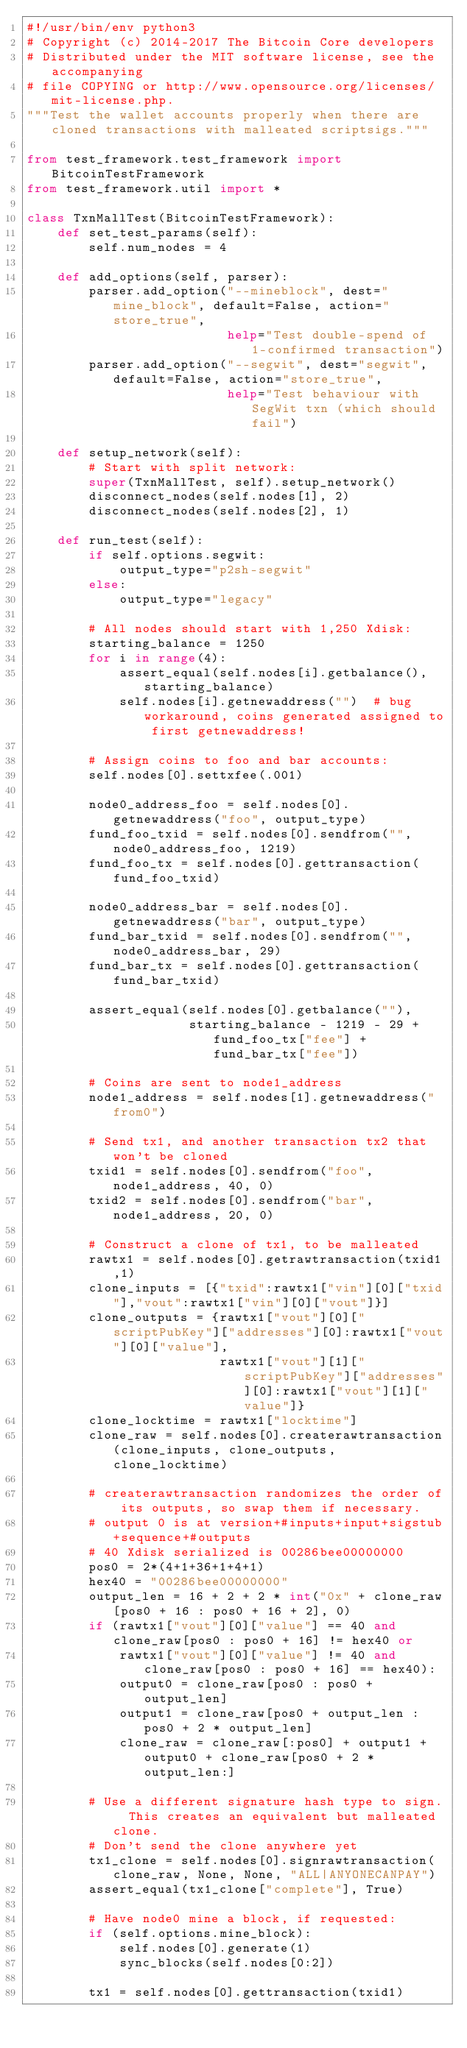<code> <loc_0><loc_0><loc_500><loc_500><_Python_>#!/usr/bin/env python3
# Copyright (c) 2014-2017 The Bitcoin Core developers
# Distributed under the MIT software license, see the accompanying
# file COPYING or http://www.opensource.org/licenses/mit-license.php.
"""Test the wallet accounts properly when there are cloned transactions with malleated scriptsigs."""

from test_framework.test_framework import BitcoinTestFramework
from test_framework.util import *

class TxnMallTest(BitcoinTestFramework):
    def set_test_params(self):
        self.num_nodes = 4

    def add_options(self, parser):
        parser.add_option("--mineblock", dest="mine_block", default=False, action="store_true",
                          help="Test double-spend of 1-confirmed transaction")
        parser.add_option("--segwit", dest="segwit", default=False, action="store_true",
                          help="Test behaviour with SegWit txn (which should fail")

    def setup_network(self):
        # Start with split network:
        super(TxnMallTest, self).setup_network()
        disconnect_nodes(self.nodes[1], 2)
        disconnect_nodes(self.nodes[2], 1)

    def run_test(self):
        if self.options.segwit:
            output_type="p2sh-segwit"
        else:
            output_type="legacy"

        # All nodes should start with 1,250 Xdisk:
        starting_balance = 1250
        for i in range(4):
            assert_equal(self.nodes[i].getbalance(), starting_balance)
            self.nodes[i].getnewaddress("")  # bug workaround, coins generated assigned to first getnewaddress!

        # Assign coins to foo and bar accounts:
        self.nodes[0].settxfee(.001)

        node0_address_foo = self.nodes[0].getnewaddress("foo", output_type)
        fund_foo_txid = self.nodes[0].sendfrom("", node0_address_foo, 1219)
        fund_foo_tx = self.nodes[0].gettransaction(fund_foo_txid)

        node0_address_bar = self.nodes[0].getnewaddress("bar", output_type)
        fund_bar_txid = self.nodes[0].sendfrom("", node0_address_bar, 29)
        fund_bar_tx = self.nodes[0].gettransaction(fund_bar_txid)

        assert_equal(self.nodes[0].getbalance(""),
                     starting_balance - 1219 - 29 + fund_foo_tx["fee"] + fund_bar_tx["fee"])

        # Coins are sent to node1_address
        node1_address = self.nodes[1].getnewaddress("from0")

        # Send tx1, and another transaction tx2 that won't be cloned 
        txid1 = self.nodes[0].sendfrom("foo", node1_address, 40, 0)
        txid2 = self.nodes[0].sendfrom("bar", node1_address, 20, 0)

        # Construct a clone of tx1, to be malleated 
        rawtx1 = self.nodes[0].getrawtransaction(txid1,1)
        clone_inputs = [{"txid":rawtx1["vin"][0]["txid"],"vout":rawtx1["vin"][0]["vout"]}]
        clone_outputs = {rawtx1["vout"][0]["scriptPubKey"]["addresses"][0]:rawtx1["vout"][0]["value"],
                         rawtx1["vout"][1]["scriptPubKey"]["addresses"][0]:rawtx1["vout"][1]["value"]}
        clone_locktime = rawtx1["locktime"]
        clone_raw = self.nodes[0].createrawtransaction(clone_inputs, clone_outputs, clone_locktime)

        # createrawtransaction randomizes the order of its outputs, so swap them if necessary.
        # output 0 is at version+#inputs+input+sigstub+sequence+#outputs
        # 40 Xdisk serialized is 00286bee00000000
        pos0 = 2*(4+1+36+1+4+1)
        hex40 = "00286bee00000000"
        output_len = 16 + 2 + 2 * int("0x" + clone_raw[pos0 + 16 : pos0 + 16 + 2], 0)
        if (rawtx1["vout"][0]["value"] == 40 and clone_raw[pos0 : pos0 + 16] != hex40 or
            rawtx1["vout"][0]["value"] != 40 and clone_raw[pos0 : pos0 + 16] == hex40):
            output0 = clone_raw[pos0 : pos0 + output_len]
            output1 = clone_raw[pos0 + output_len : pos0 + 2 * output_len]
            clone_raw = clone_raw[:pos0] + output1 + output0 + clone_raw[pos0 + 2 * output_len:]

        # Use a different signature hash type to sign.  This creates an equivalent but malleated clone.
        # Don't send the clone anywhere yet
        tx1_clone = self.nodes[0].signrawtransaction(clone_raw, None, None, "ALL|ANYONECANPAY")
        assert_equal(tx1_clone["complete"], True)

        # Have node0 mine a block, if requested:
        if (self.options.mine_block):
            self.nodes[0].generate(1)
            sync_blocks(self.nodes[0:2])

        tx1 = self.nodes[0].gettransaction(txid1)</code> 